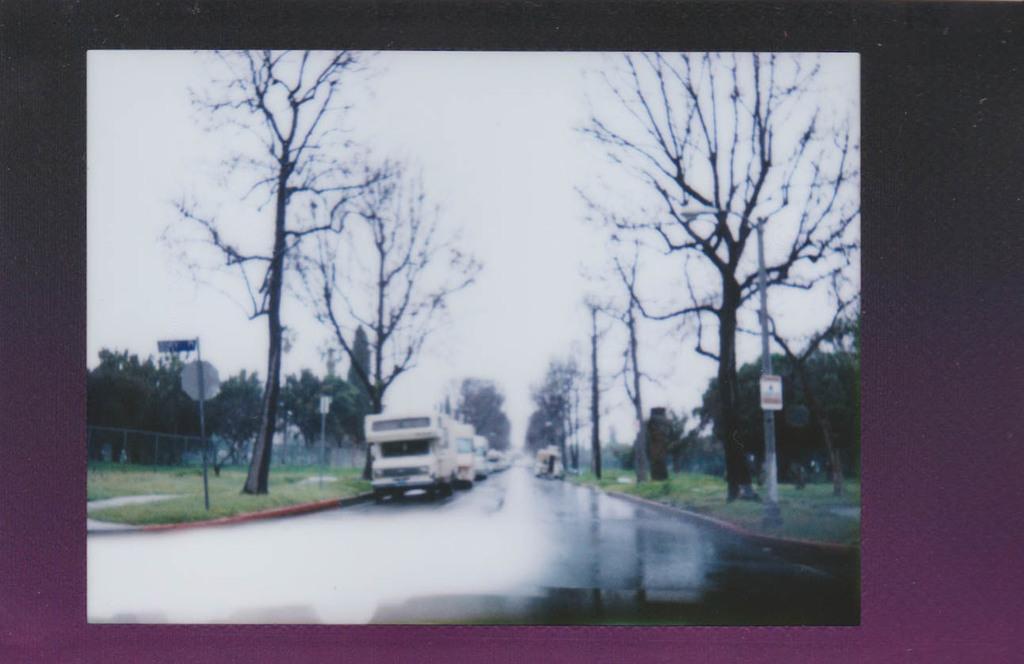Describe this image in one or two sentences. These are trees, there are vehicles on the road, this is sky. 